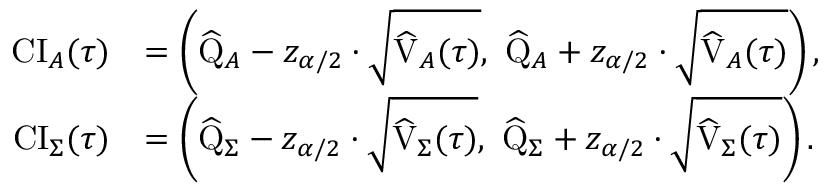Convert formula to latex. <formula><loc_0><loc_0><loc_500><loc_500>\begin{array} { r l } { C I _ { A } ( \tau ) } & { = \left ( \widehat { Q } _ { A } - { z _ { \alpha / 2 } } \cdot \sqrt { \widehat { V } _ { A } ( \tau ) } , \, \widehat { Q } _ { A } + { z _ { \alpha / 2 } } \cdot \sqrt { \widehat { V } _ { A } ( \tau ) } \right ) , } \\ { C I _ { \Sigma } ( \tau ) } & { = \left ( \widehat { Q } _ { \Sigma } - { z _ { \alpha / 2 } } \cdot \sqrt { \widehat { V } _ { \Sigma } ( \tau ) } , \, \widehat { Q } _ { \Sigma } + { z _ { \alpha / 2 } } \cdot \sqrt { \widehat { V } _ { \Sigma } ( \tau ) } \right ) . } \end{array}</formula> 